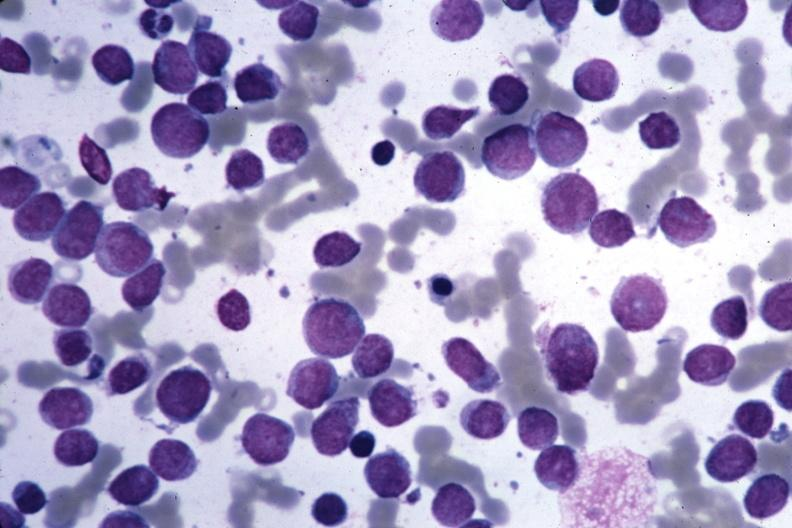s mucoepidermoid carcinoma present?
Answer the question using a single word or phrase. No 